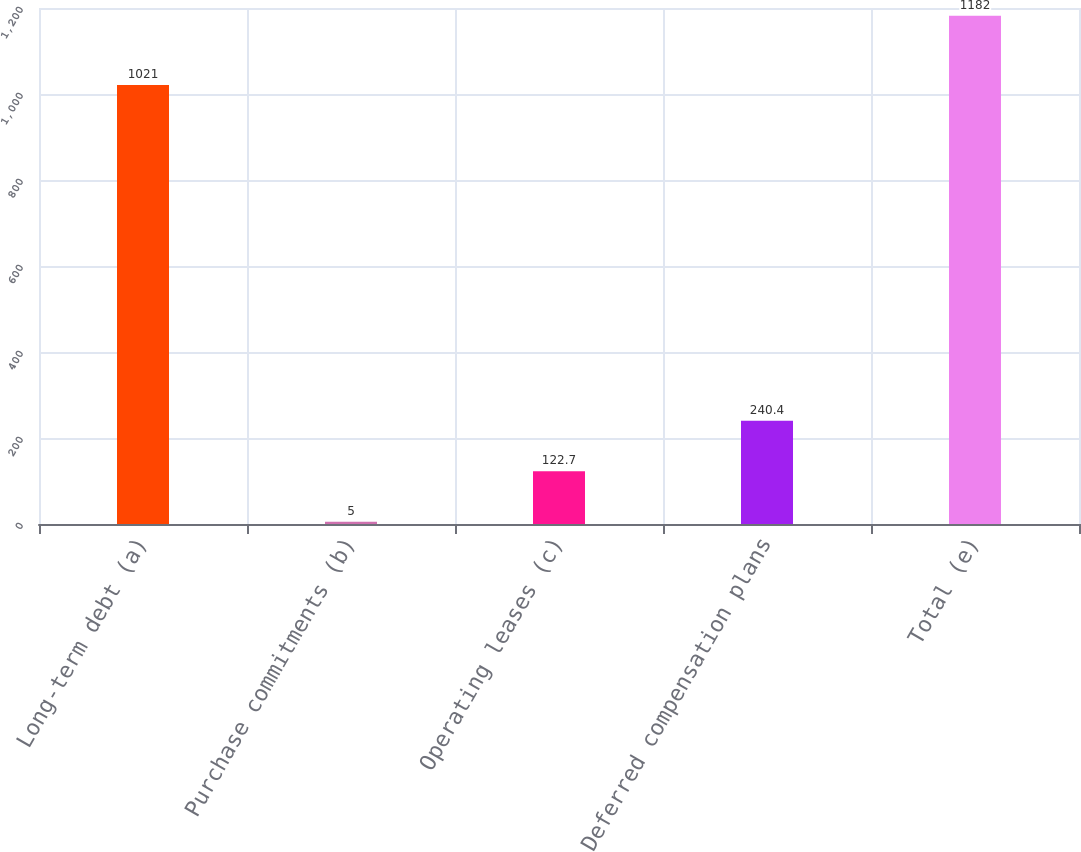<chart> <loc_0><loc_0><loc_500><loc_500><bar_chart><fcel>Long-term debt (a)<fcel>Purchase commitments (b)<fcel>Operating leases (c)<fcel>Deferred compensation plans<fcel>Total (e)<nl><fcel>1021<fcel>5<fcel>122.7<fcel>240.4<fcel>1182<nl></chart> 